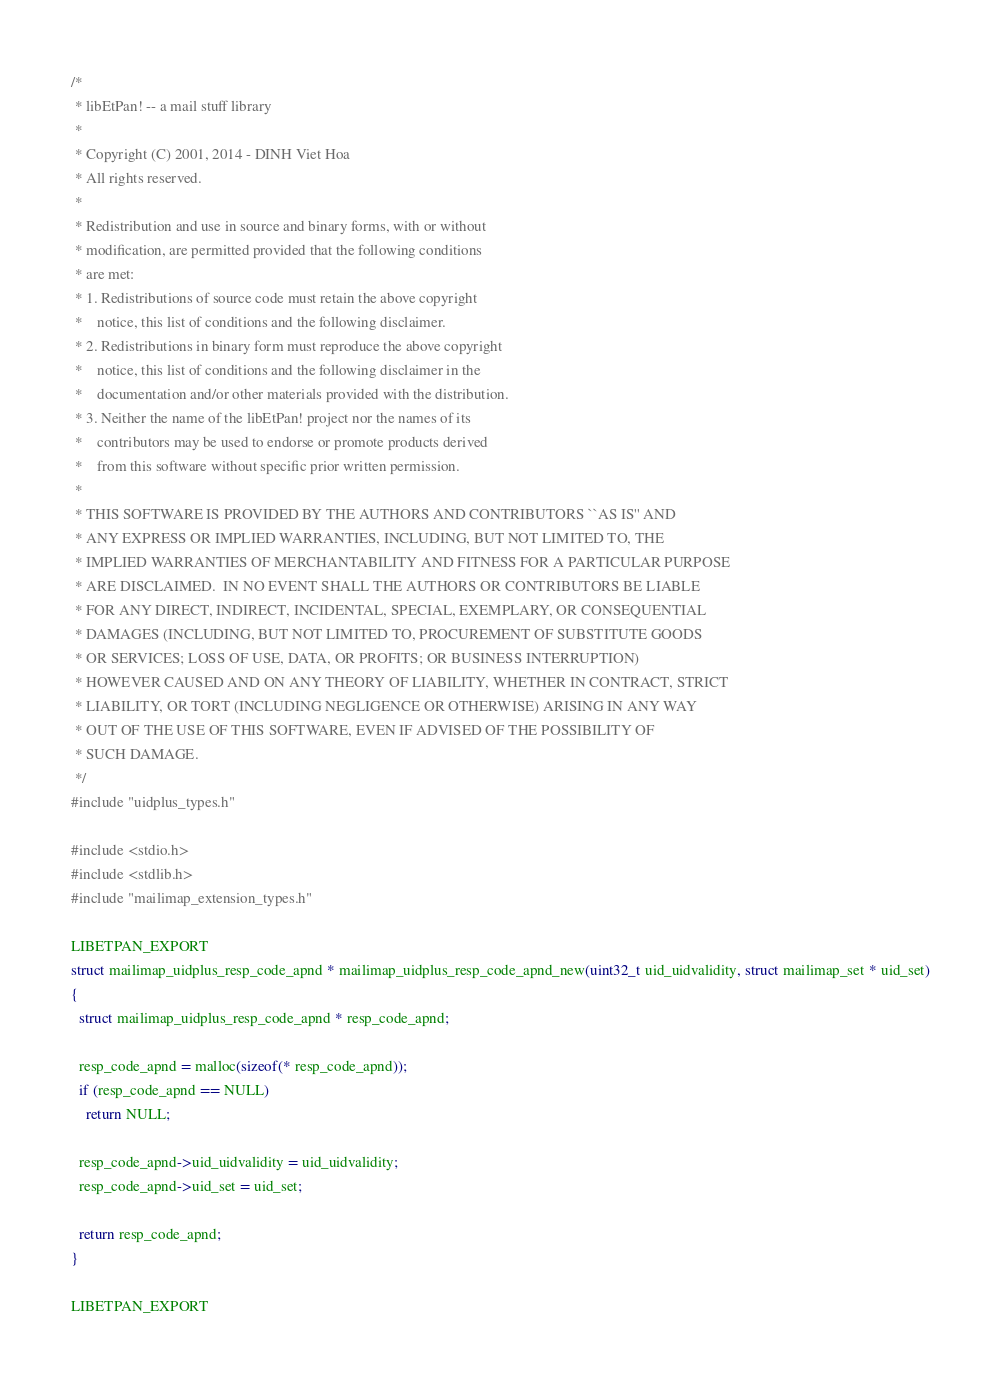<code> <loc_0><loc_0><loc_500><loc_500><_C_>/*
 * libEtPan! -- a mail stuff library
 *
 * Copyright (C) 2001, 2014 - DINH Viet Hoa
 * All rights reserved.
 *
 * Redistribution and use in source and binary forms, with or without
 * modification, are permitted provided that the following conditions
 * are met:
 * 1. Redistributions of source code must retain the above copyright
 *    notice, this list of conditions and the following disclaimer.
 * 2. Redistributions in binary form must reproduce the above copyright
 *    notice, this list of conditions and the following disclaimer in the
 *    documentation and/or other materials provided with the distribution.
 * 3. Neither the name of the libEtPan! project nor the names of its
 *    contributors may be used to endorse or promote products derived
 *    from this software without specific prior written permission.
 *
 * THIS SOFTWARE IS PROVIDED BY THE AUTHORS AND CONTRIBUTORS ``AS IS'' AND
 * ANY EXPRESS OR IMPLIED WARRANTIES, INCLUDING, BUT NOT LIMITED TO, THE
 * IMPLIED WARRANTIES OF MERCHANTABILITY AND FITNESS FOR A PARTICULAR PURPOSE
 * ARE DISCLAIMED.  IN NO EVENT SHALL THE AUTHORS OR CONTRIBUTORS BE LIABLE
 * FOR ANY DIRECT, INDIRECT, INCIDENTAL, SPECIAL, EXEMPLARY, OR CONSEQUENTIAL
 * DAMAGES (INCLUDING, BUT NOT LIMITED TO, PROCUREMENT OF SUBSTITUTE GOODS
 * OR SERVICES; LOSS OF USE, DATA, OR PROFITS; OR BUSINESS INTERRUPTION)
 * HOWEVER CAUSED AND ON ANY THEORY OF LIABILITY, WHETHER IN CONTRACT, STRICT
 * LIABILITY, OR TORT (INCLUDING NEGLIGENCE OR OTHERWISE) ARISING IN ANY WAY
 * OUT OF THE USE OF THIS SOFTWARE, EVEN IF ADVISED OF THE POSSIBILITY OF
 * SUCH DAMAGE.
 */
#include "uidplus_types.h"

#include <stdio.h>
#include <stdlib.h>
#include "mailimap_extension_types.h"

LIBETPAN_EXPORT
struct mailimap_uidplus_resp_code_apnd * mailimap_uidplus_resp_code_apnd_new(uint32_t uid_uidvalidity, struct mailimap_set * uid_set)
{
  struct mailimap_uidplus_resp_code_apnd * resp_code_apnd;
  
  resp_code_apnd = malloc(sizeof(* resp_code_apnd));
  if (resp_code_apnd == NULL)
    return NULL;
  
  resp_code_apnd->uid_uidvalidity = uid_uidvalidity;
  resp_code_apnd->uid_set = uid_set;
  
  return resp_code_apnd;
}

LIBETPAN_EXPORT</code> 